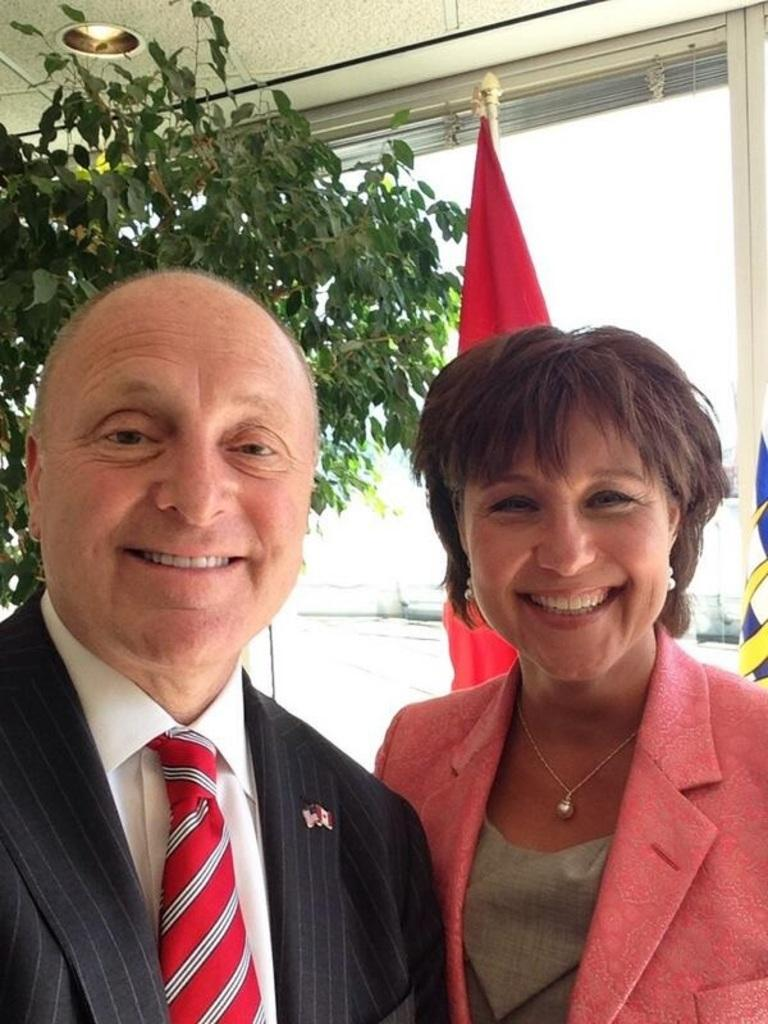How many people are in the image? There are two persons standing in the image. What is the facial expression of the persons? The persons are smiling. What natural element can be seen in the image? There is a tree visible in the image. What symbol or emblem is present in the image? There is a flag in the image. What type of artificial light source is visible in the image? There is a ceiling light in the image. What architectural feature allows for natural light to enter the space? There is a glass window in the image. Where is the scarecrow standing in the image? There is no scarecrow present in the image. What type of sea creature can be seen swimming in the image? There is no sea creature visible in the image. 